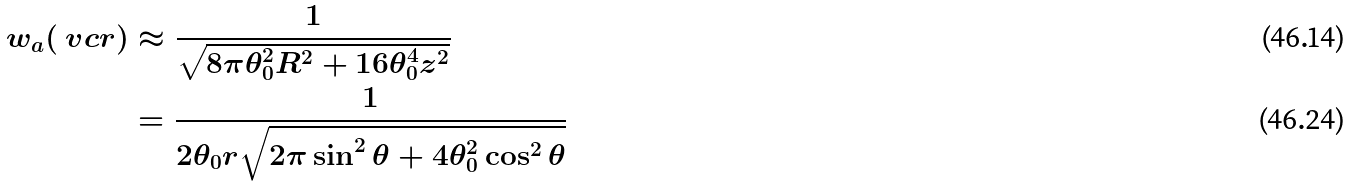<formula> <loc_0><loc_0><loc_500><loc_500>w _ { a } ( \ v c { r } ) & \approx \frac { 1 } { \sqrt { 8 \pi \theta _ { 0 } ^ { 2 } R ^ { 2 } + 1 6 \theta _ { 0 } ^ { 4 } z ^ { 2 } } } \\ & = \frac { 1 } { 2 \theta _ { 0 } r \sqrt { 2 \pi \sin ^ { 2 } \theta + 4 \theta _ { 0 } ^ { 2 } \cos ^ { 2 } \theta } }</formula> 